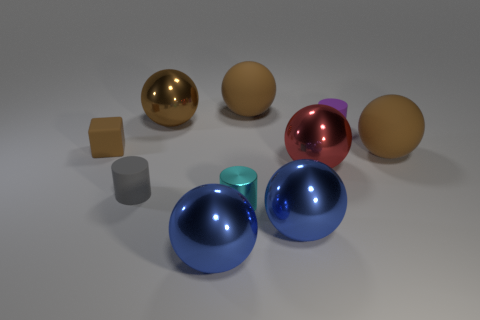There is a matte thing that is both left of the tiny purple cylinder and in front of the cube; what shape is it?
Keep it short and to the point. Cylinder. What number of green things are either large matte objects or cylinders?
Offer a very short reply. 0. Is the size of the brown ball that is on the left side of the tiny cyan metallic thing the same as the rubber ball to the right of the large red metallic thing?
Your response must be concise. Yes. How many objects are matte cylinders or purple cylinders?
Your response must be concise. 2. Are there any other metallic things that have the same shape as the gray thing?
Offer a very short reply. Yes. Are there fewer brown things than rubber blocks?
Offer a terse response. No. Does the red metallic object have the same shape as the big brown shiny thing?
Your response must be concise. Yes. What number of objects are gray cylinders or brown matte balls that are in front of the small rubber block?
Keep it short and to the point. 2. What number of tiny gray rubber cylinders are there?
Provide a succinct answer. 1. Is there a cyan cylinder that has the same size as the gray rubber thing?
Ensure brevity in your answer.  Yes. 